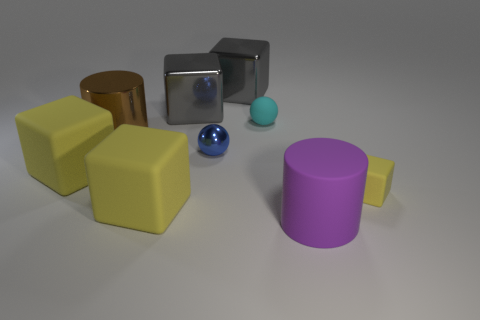There is a cube that is both to the right of the tiny blue object and in front of the big brown thing; what is its material?
Make the answer very short. Rubber. Do the metal ball and the matte sphere have the same size?
Provide a succinct answer. Yes. There is a gray metal cube behind the big gray cube to the left of the small blue metal ball; how big is it?
Keep it short and to the point. Large. How many matte cubes are both on the left side of the small cyan rubber object and on the right side of the big brown metal cylinder?
Your response must be concise. 1. There is a tiny shiny sphere left of the big cylinder that is in front of the small yellow cube; is there a large thing behind it?
Offer a terse response. Yes. What shape is the purple object that is the same size as the brown metal cylinder?
Provide a succinct answer. Cylinder. Is there a big rubber block of the same color as the small rubber sphere?
Keep it short and to the point. No. Does the cyan matte object have the same shape as the purple object?
Your answer should be compact. No. What number of small things are either cyan matte things or blue objects?
Offer a very short reply. 2. What is the color of the small block that is made of the same material as the big purple thing?
Ensure brevity in your answer.  Yellow. 